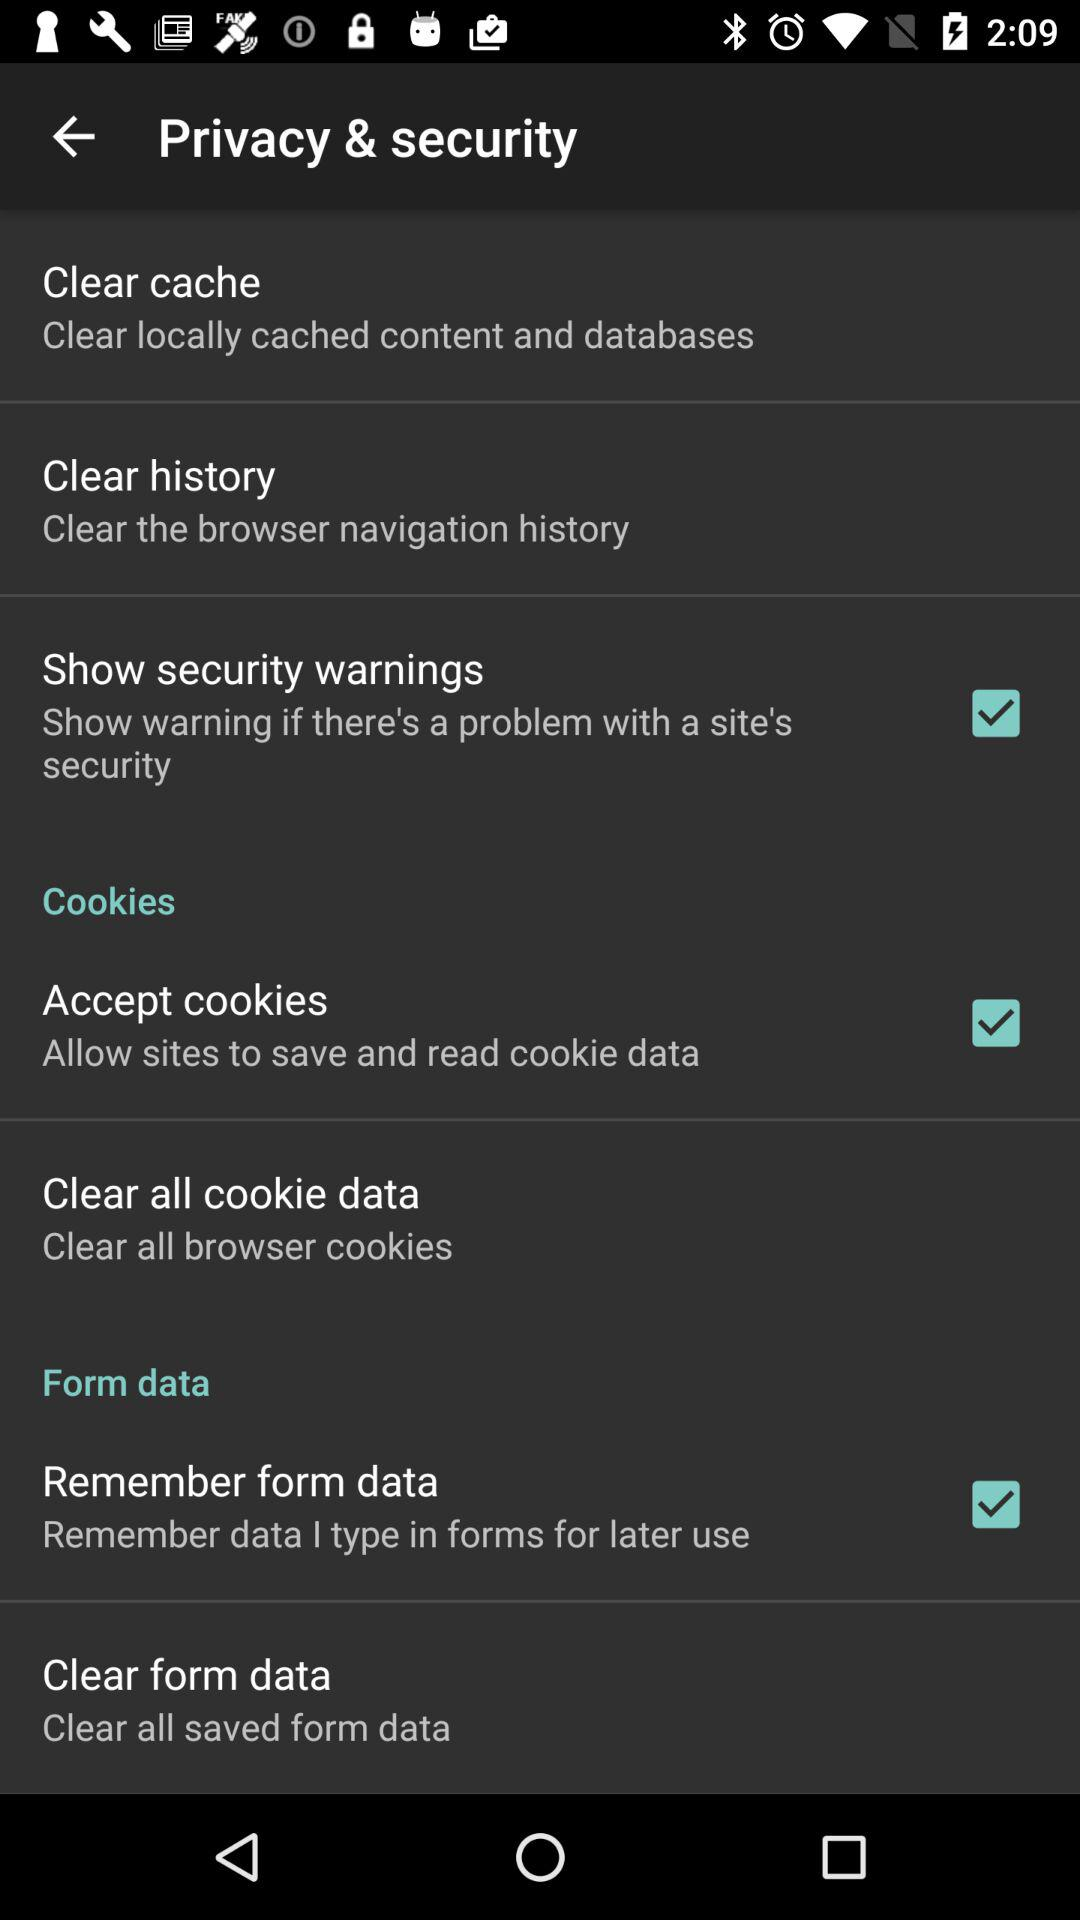What is the current status of "Remember form data"? The current status of "Remember form data" is "on". 